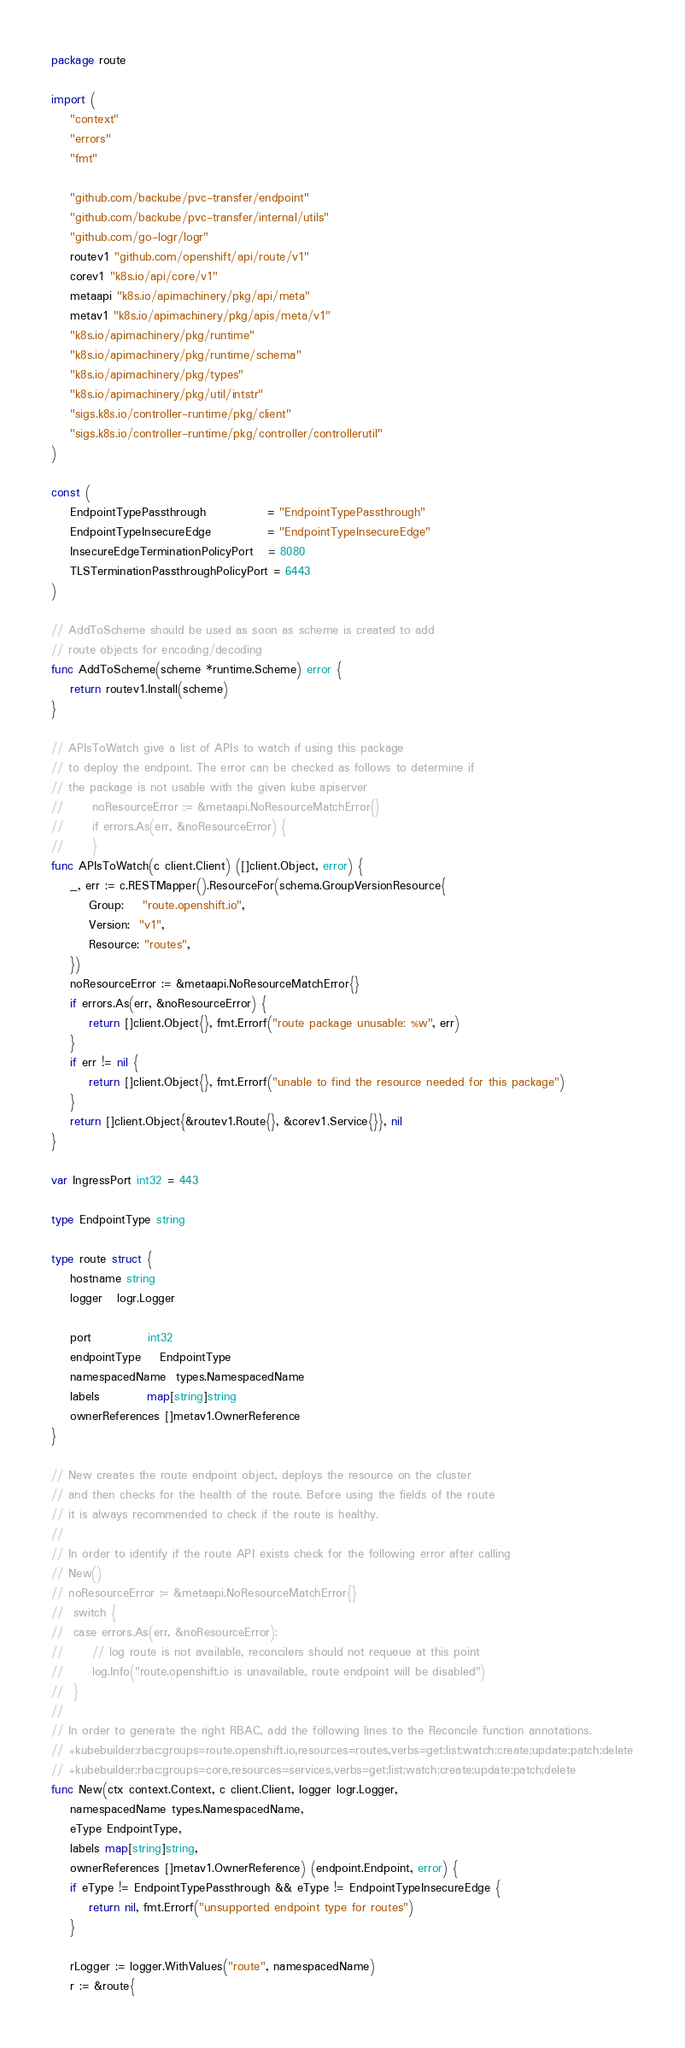Convert code to text. <code><loc_0><loc_0><loc_500><loc_500><_Go_>package route

import (
	"context"
	"errors"
	"fmt"

	"github.com/backube/pvc-transfer/endpoint"
	"github.com/backube/pvc-transfer/internal/utils"
	"github.com/go-logr/logr"
	routev1 "github.com/openshift/api/route/v1"
	corev1 "k8s.io/api/core/v1"
	metaapi "k8s.io/apimachinery/pkg/api/meta"
	metav1 "k8s.io/apimachinery/pkg/apis/meta/v1"
	"k8s.io/apimachinery/pkg/runtime"
	"k8s.io/apimachinery/pkg/runtime/schema"
	"k8s.io/apimachinery/pkg/types"
	"k8s.io/apimachinery/pkg/util/intstr"
	"sigs.k8s.io/controller-runtime/pkg/client"
	"sigs.k8s.io/controller-runtime/pkg/controller/controllerutil"
)

const (
	EndpointTypePassthrough             = "EndpointTypePassthrough"
	EndpointTypeInsecureEdge            = "EndpointTypeInsecureEdge"
	InsecureEdgeTerminationPolicyPort   = 8080
	TLSTerminationPassthroughPolicyPort = 6443
)

// AddToScheme should be used as soon as scheme is created to add
// route objects for encoding/decoding
func AddToScheme(scheme *runtime.Scheme) error {
	return routev1.Install(scheme)
}

// APIsToWatch give a list of APIs to watch if using this package
// to deploy the endpoint. The error can be checked as follows to determine if
// the package is not usable with the given kube apiserver
//  	noResourceError := &metaapi.NoResourceMatchError{}
//		if errors.As(err, &noResourceError) {
// 		}
func APIsToWatch(c client.Client) ([]client.Object, error) {
	_, err := c.RESTMapper().ResourceFor(schema.GroupVersionResource{
		Group:    "route.openshift.io",
		Version:  "v1",
		Resource: "routes",
	})
	noResourceError := &metaapi.NoResourceMatchError{}
	if errors.As(err, &noResourceError) {
		return []client.Object{}, fmt.Errorf("route package unusable: %w", err)
	}
	if err != nil {
		return []client.Object{}, fmt.Errorf("unable to find the resource needed for this package")
	}
	return []client.Object{&routev1.Route{}, &corev1.Service{}}, nil
}

var IngressPort int32 = 443

type EndpointType string

type route struct {
	hostname string
	logger   logr.Logger

	port            int32
	endpointType    EndpointType
	namespacedName  types.NamespacedName
	labels          map[string]string
	ownerReferences []metav1.OwnerReference
}

// New creates the route endpoint object, deploys the resource on the cluster
// and then checks for the health of the route. Before using the fields of the route
// it is always recommended to check if the route is healthy.
//
// In order to identify if the route API exists check for the following error after calling
// New()
// noResourceError := &metaapi.NoResourceMatchError{}
//	switch {
//	case errors.As(err, &noResourceError):
//		// log route is not available, reconcilers should not requeue at this point
//		log.Info("route.openshift.io is unavailable, route endpoint will be disabled")
//  }
//
// In order to generate the right RBAC, add the following lines to the Reconcile function annotations.
// +kubebuilder:rbac:groups=route.openshift.io,resources=routes,verbs=get;list;watch;create;update;patch;delete
// +kubebuilder:rbac:groups=core,resources=services,verbs=get;list;watch;create;update;patch;delete
func New(ctx context.Context, c client.Client, logger logr.Logger,
	namespacedName types.NamespacedName,
	eType EndpointType,
	labels map[string]string,
	ownerReferences []metav1.OwnerReference) (endpoint.Endpoint, error) {
	if eType != EndpointTypePassthrough && eType != EndpointTypeInsecureEdge {
		return nil, fmt.Errorf("unsupported endpoint type for routes")
	}

	rLogger := logger.WithValues("route", namespacedName)
	r := &route{</code> 